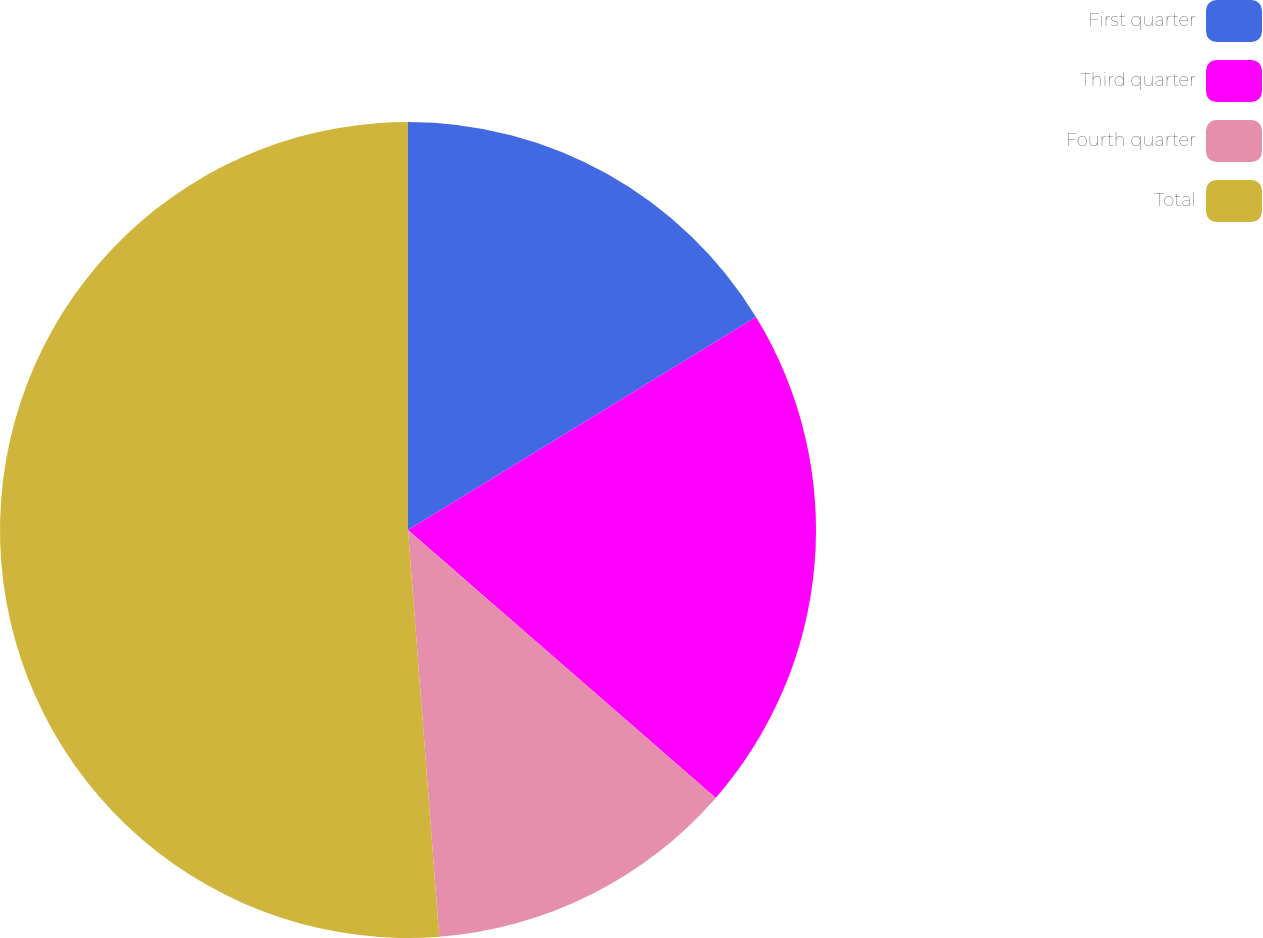Convert chart. <chart><loc_0><loc_0><loc_500><loc_500><pie_chart><fcel>First quarter<fcel>Third quarter<fcel>Fourth quarter<fcel>Total<nl><fcel>16.26%<fcel>20.14%<fcel>12.38%<fcel>51.22%<nl></chart> 